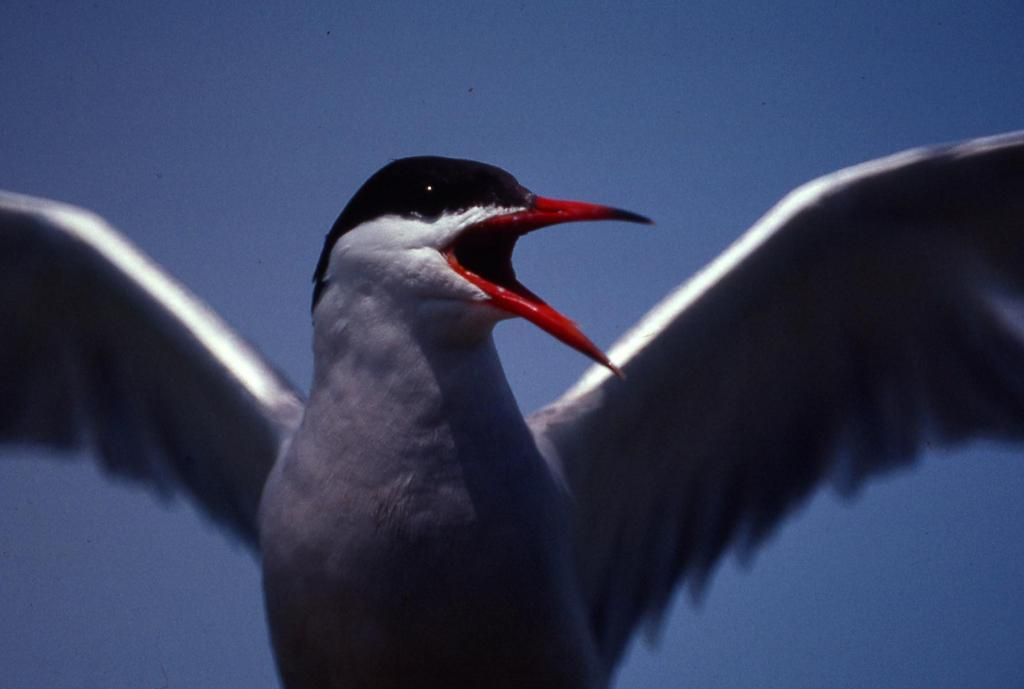What type of animal is present in the image? There is a bird in the image. What type of iron is being used by the bird in the image? There is no iron present in the image, as it features a bird. What type of bells can be heard ringing in the background of the image? There is no sound or reference to bells in the image, as it only shows a bird. 